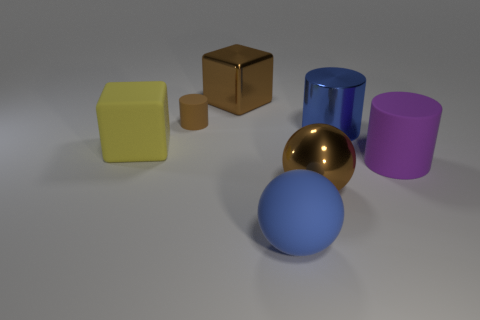Add 2 cylinders. How many objects exist? 9 Subtract all spheres. How many objects are left? 5 Subtract all tiny yellow metal balls. Subtract all rubber spheres. How many objects are left? 6 Add 6 small brown things. How many small brown things are left? 7 Add 7 blue cylinders. How many blue cylinders exist? 8 Subtract 0 blue cubes. How many objects are left? 7 